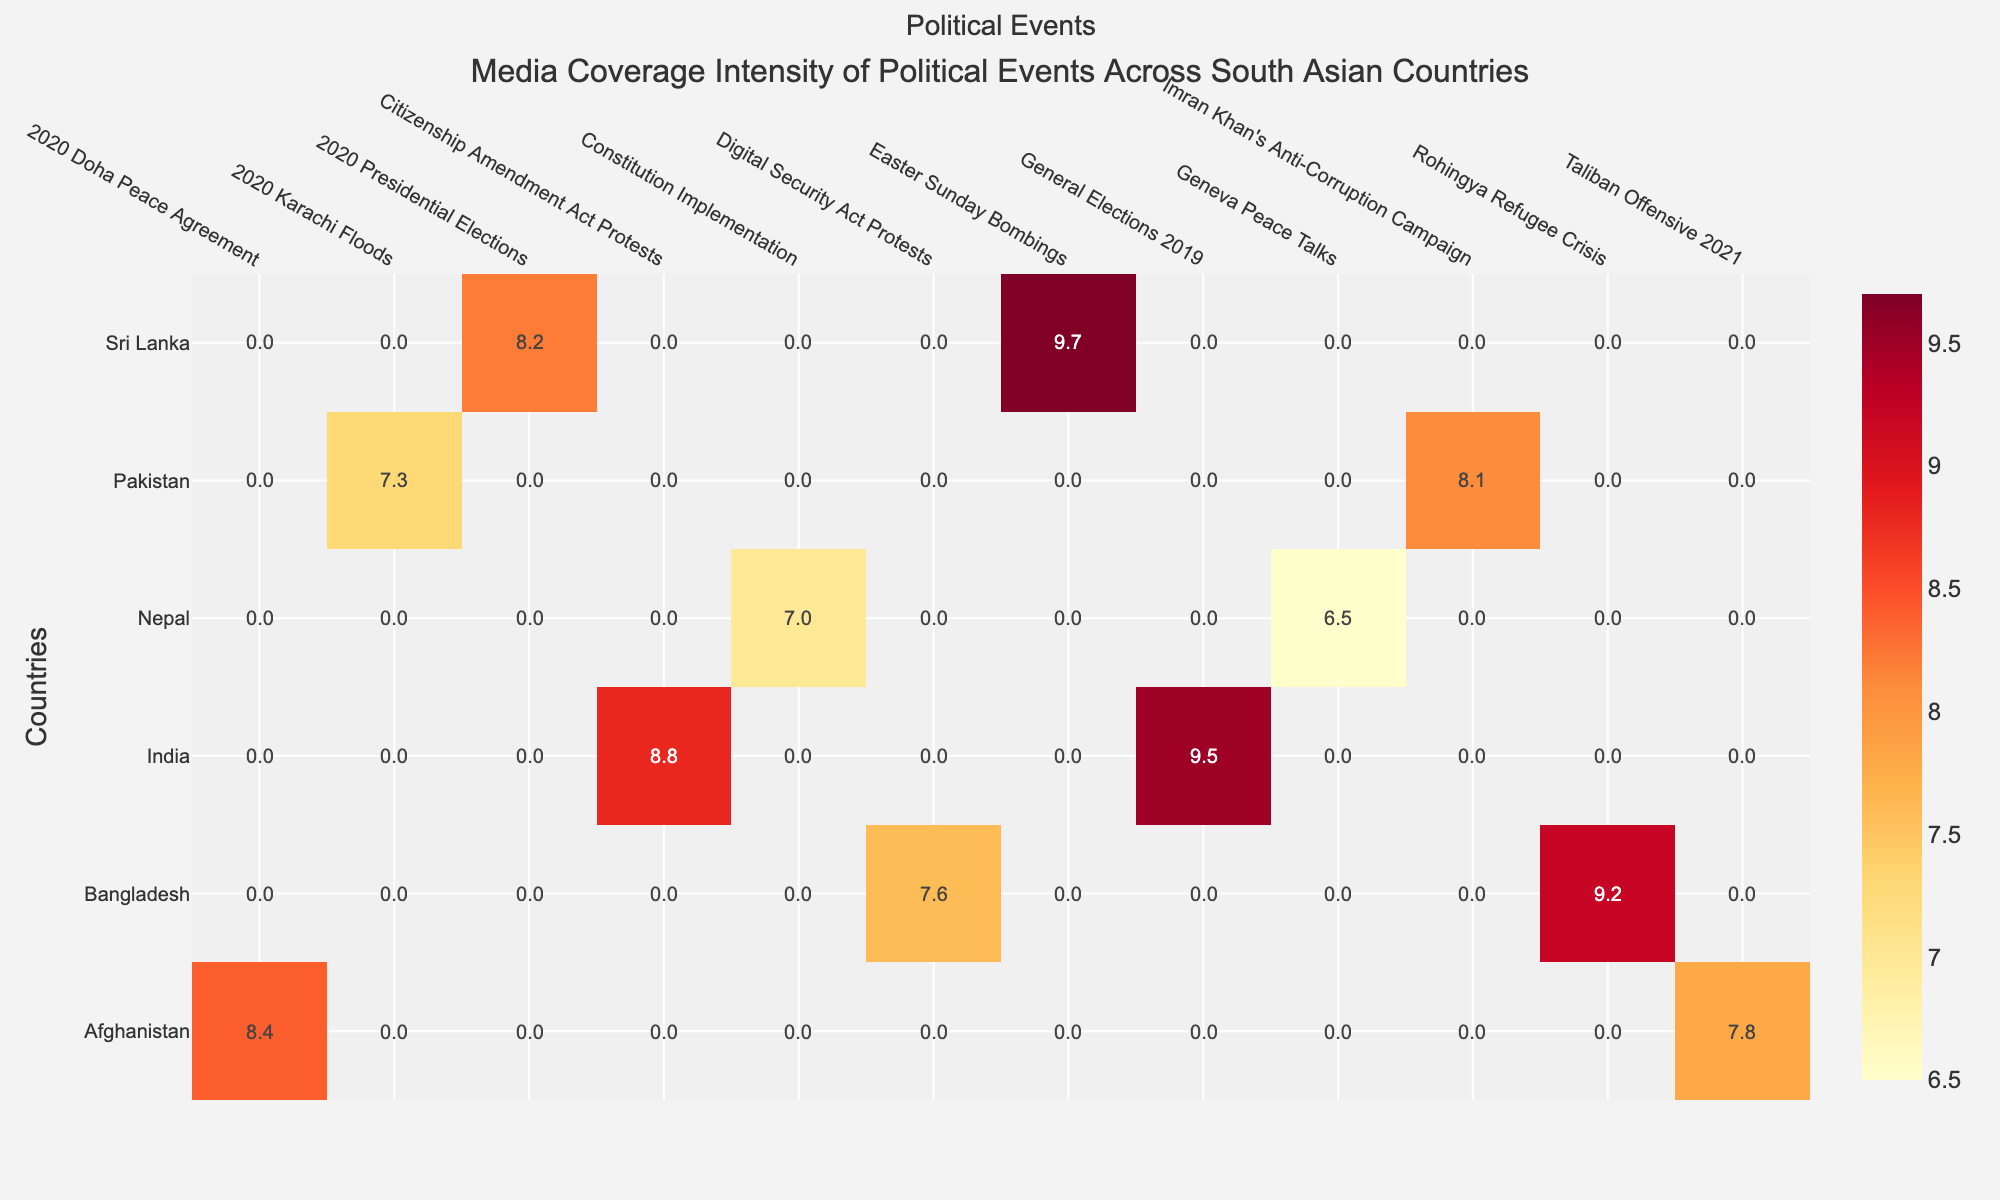What is the title of the heatmap? Look at the top of the heatmap where the title is typically placed. It displays the main topic of the visualization.
Answer: Media Coverage Intensity of Political Events Across South Asian Countries Which political event in India received the highest media coverage score? Check the row corresponding to India and identify the cell with the highest score.
Answer: General Elections 2019 What is the average media coverage score for political events in Afghanistan? Locate the row for Afghanistan, sum the scores for both events (8.4 + 7.8 = 16.2), and divide by the number of events (2).
Answer: 8.1 Which country had the lowest media coverage score for any political event? Scan through all the scores to find the smallest value.
Answer: Nepal Compare the media coverage scores of the Rohingya Refugee Crisis and the Citizenship Amendment Act Protests. Which event had a higher score and by how much? Identify the scores of both events (Rohingya Refugee Crisis: 9.2, Citizenship Amendment Act Protests: 8.8) and calculate the difference (9.2 - 8.8 = 0.4).
Answer: Rohingya Refugee Crisis, by 0.4 Are there any political events with a media coverage score above 9, and if so, which countries do they belong to? Look for scores greater than 9 and identify the corresponding countries.
Answer: India, Bangladesh, Sri Lanka What is the total media coverage score for Sri Lanka across all recorded events? Add the coverage scores for both events in Sri Lanka (9.7 + 8.2).
Answer: 17.9 Which country had the highest media coverage score for a single event, and what was that score? Identify the highest score in the heatmap and note the country and event associated with it.
Answer: Sri Lanka, 9.7 (Easter Sunday Bombings) How does the media coverage score for the 2020 Doha Peace Agreement in Afghanistan compare to the 2020 Presidential Elections in Sri Lanka? Identify the scores (8.4 for 2020 Doha Peace Agreement and 8.2 for 2020 Presidential Elections) and compare them.
Answer: 2020 Doha Peace Agreement is higher by 0.2 points What is the range of media coverage scores in the heatmap? Identify the highest and lowest scores, then subtract the lowest score from the highest score (9.7 - 6.5).
Answer: 3.2 